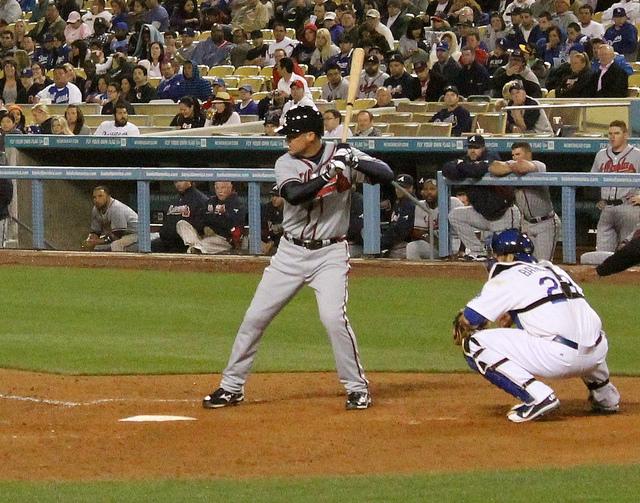What color is the player's shirt?
Short answer required. Gray. What is the man called behind the batter?
Write a very short answer. Catcher. Where is the person who is waiting to bat?
Short answer required. Dugout. How many people are pictured?
Short answer required. 2. Are they playing golf?
Be succinct. No. 